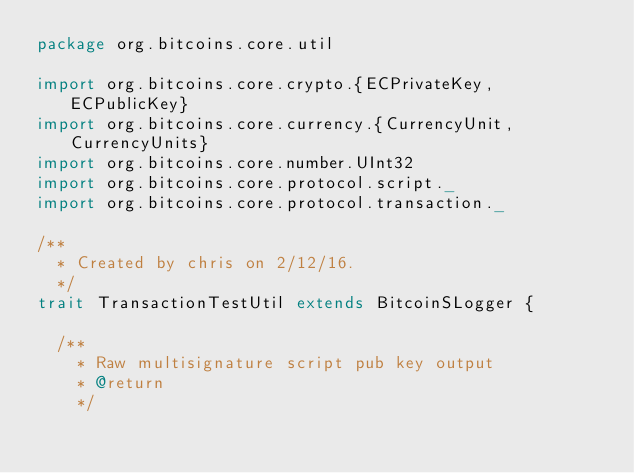Convert code to text. <code><loc_0><loc_0><loc_500><loc_500><_Scala_>package org.bitcoins.core.util

import org.bitcoins.core.crypto.{ECPrivateKey, ECPublicKey}
import org.bitcoins.core.currency.{CurrencyUnit, CurrencyUnits}
import org.bitcoins.core.number.UInt32
import org.bitcoins.core.protocol.script._
import org.bitcoins.core.protocol.transaction._

/**
  * Created by chris on 2/12/16.
  */
trait TransactionTestUtil extends BitcoinSLogger {

  /**
    * Raw multisignature script pub key output
    * @return
    */</code> 